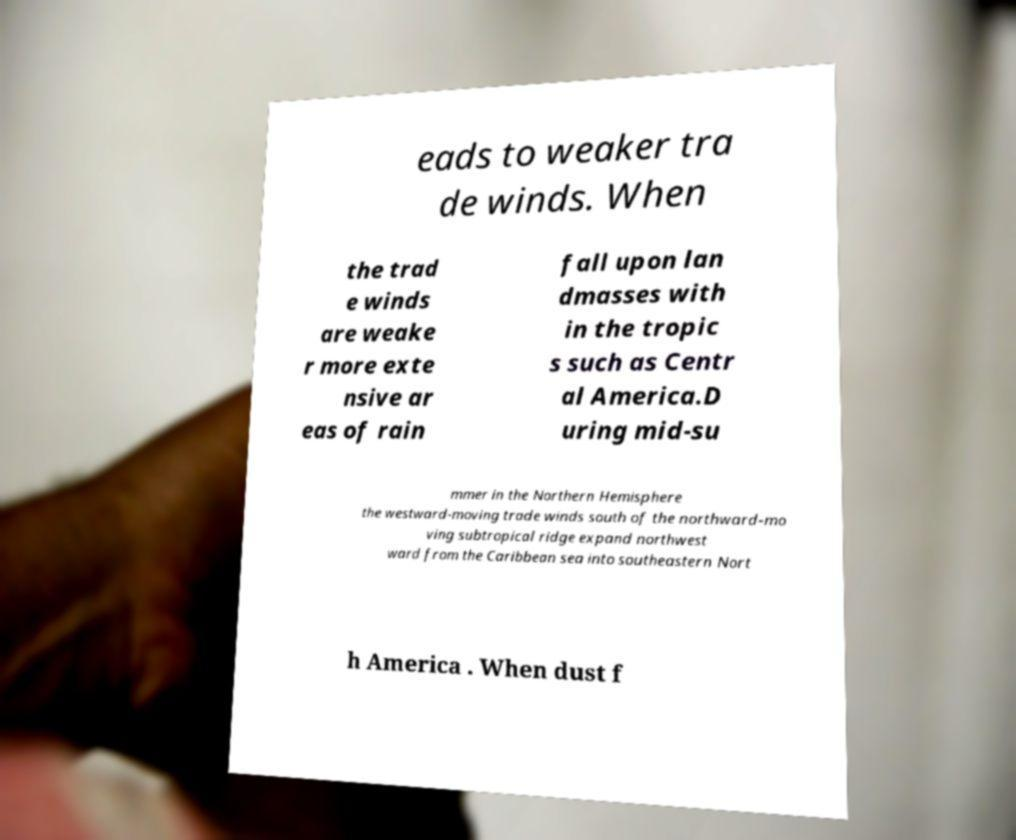Could you extract and type out the text from this image? eads to weaker tra de winds. When the trad e winds are weake r more exte nsive ar eas of rain fall upon lan dmasses with in the tropic s such as Centr al America.D uring mid-su mmer in the Northern Hemisphere the westward-moving trade winds south of the northward-mo ving subtropical ridge expand northwest ward from the Caribbean sea into southeastern Nort h America . When dust f 